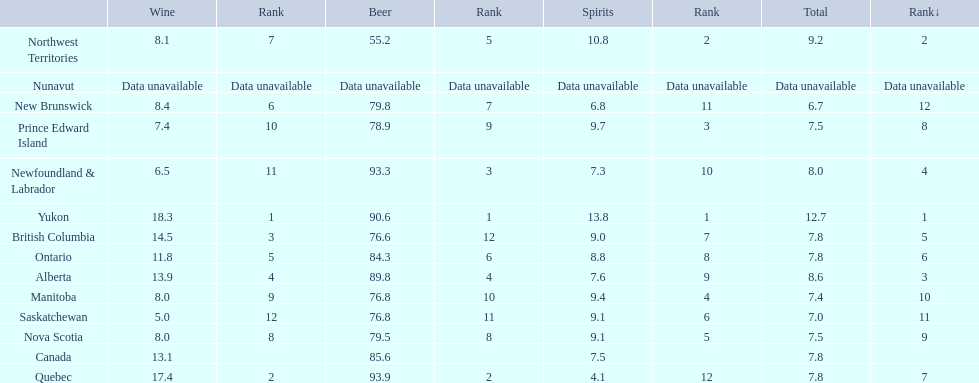Where do people consume the highest average of spirits per year? Yukon. How many liters on average do people here drink per year of spirits? 12.7. 